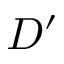<formula> <loc_0><loc_0><loc_500><loc_500>D ^ { \prime }</formula> 